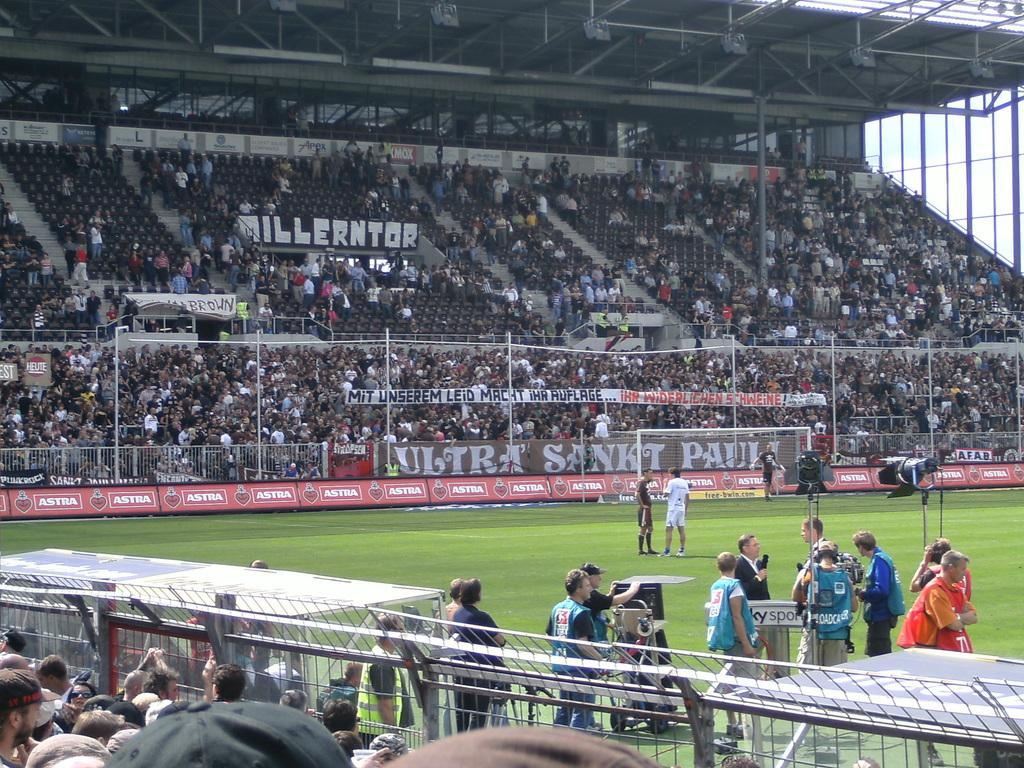What is happening in the image? There is a group of people standing in the image. Can you describe the person in front of the group? The person in front is wearing a blue jacket. What can be seen in the background of the image? There is railing visible in the background of the image. Are there any other people in the image besides the standing group? Yes, there are other persons sitting in the background of the image. What type of destruction can be seen in the image? There is no destruction present in the image; it features a group of people standing and other persons sitting in the background. How many bells are hanging from the person in the blue jacket? There are no bells visible on the person in the blue jacket or in the image. 